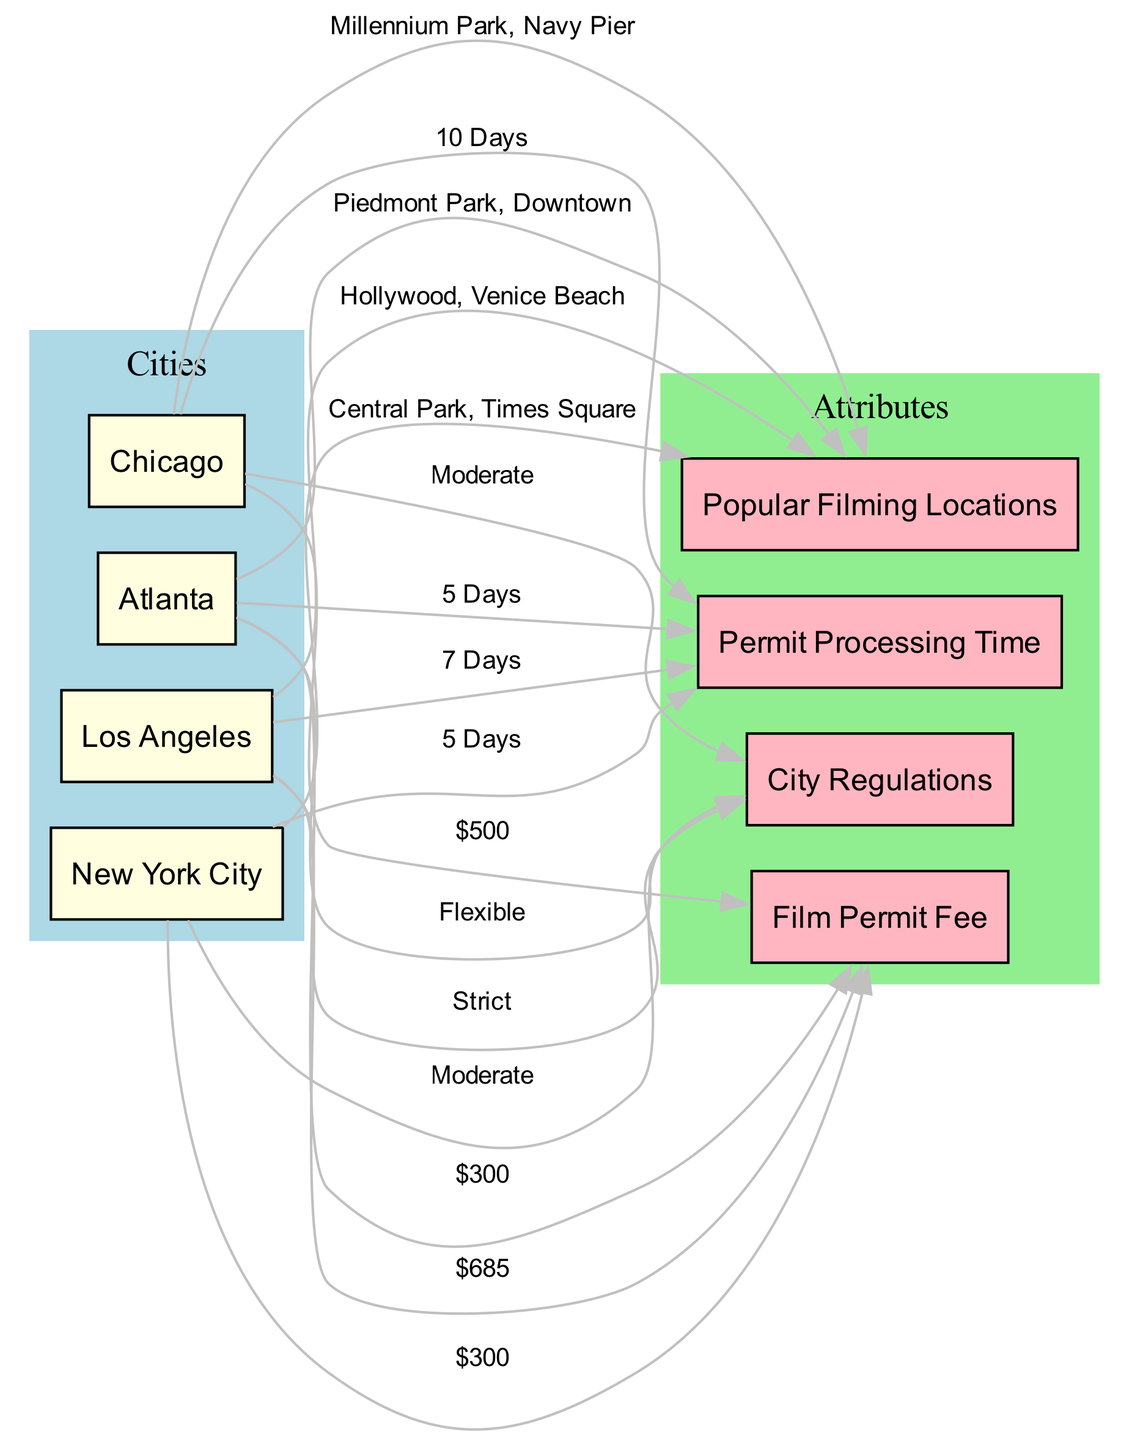What is the film permit fee for Los Angeles? The film permit fee for Los Angeles is directly linked through an edge labeled "$685" connecting Los Angeles to Film Permit Fee in the diagram.
Answer: $685 What is the permit processing time for New York City? In the diagram, New York City is connected to Permit Processing Time with an edge labeled "5 Days." Thus, the processing time for permits is five days.
Answer: 5 Days Which city has the lowest film permit fee? By examining the edges for Film Permit Fee, both Atlanta and New York City have the same fee of "$300," which is lower than the other cities listed in the diagram.
Answer: $300 What popular filming locations are associated with Chicago? Chicago is linked to Popular Locations in the diagram, indicated by the edge labeled "Millennium Park, Navy Pier." These are the noted filming locations for Chicago.
Answer: Millennium Park, Navy Pier Which city has the strictest city regulations? The diagram shows that Los Angeles, with an edge labeled "Strict" connected to City Regulations, indicates it has the most stringent regulations compared to the other cities presented.
Answer: Strict How many days does it take to process a film permit in Atlanta? By reviewing the edges, the connection from Atlanta to Permit Processing Time is labeled "5 Days," meaning it takes five days to process a permit here.
Answer: 5 Days What are the popular filming locations in New York City? The edge connecting New York City to Popular Locations in the diagram is labeled "Central Park, Times Square," indicating these are the notable filming spots in the city.
Answer: Central Park, Times Square Which city has the most flexible city regulations? Atlanta has the edge labeled "Flexible" connecting it to City Regulations, indicating that it features the most accommodating regulations compared to the others.
Answer: Flexible 